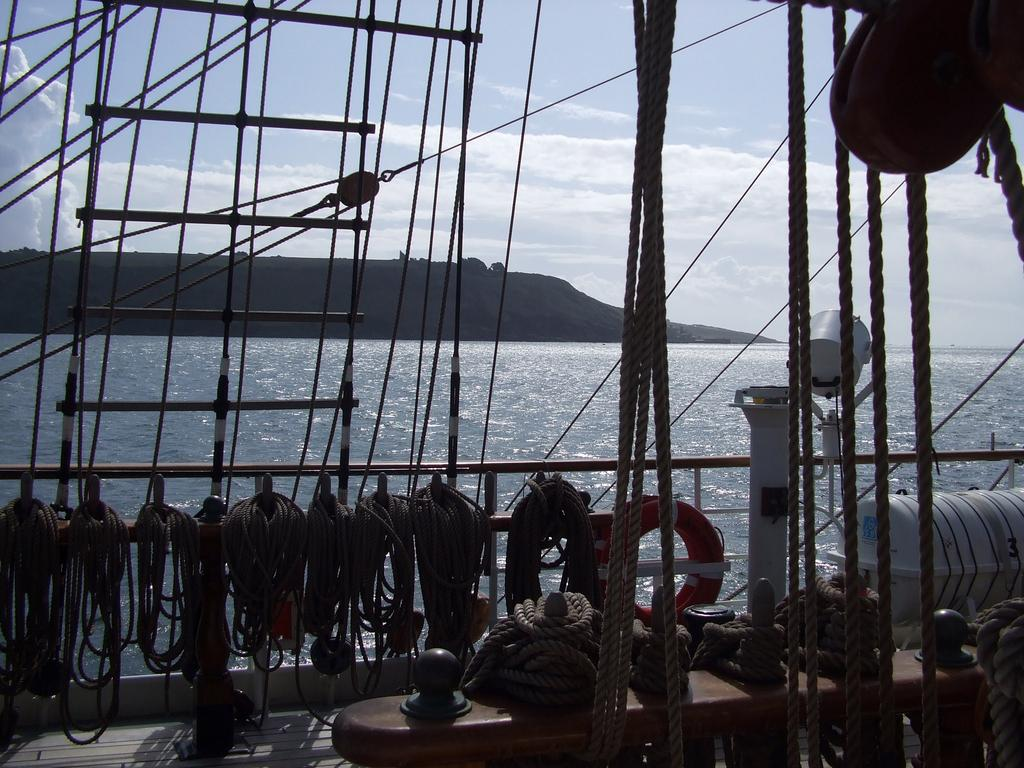What type of objects can be seen in the image related to water safety? In the image, there are ropes, a lifeboat, a barrel, and a lifebuoy related to water safety. What is the primary purpose of the lifeboat in the image? The primary purpose of the lifeboat in the image is to provide a means of escape or rescue in case of emergency. What other objects can be seen in the image besides those related to water safety? In the image, there is also water visible, a hill, and a lifebuoy. What can be seen in the background of the image? In the background of the image, the sky is visible. What type of marble is being used to build the hill in the image? There is no marble present in the image; the hill is a natural formation. Is there a ray visible in the image? There is no ray present in the image; it features ropes, a lifeboat, a barrel, a lifebuoy, water, a hill, and the sky. 